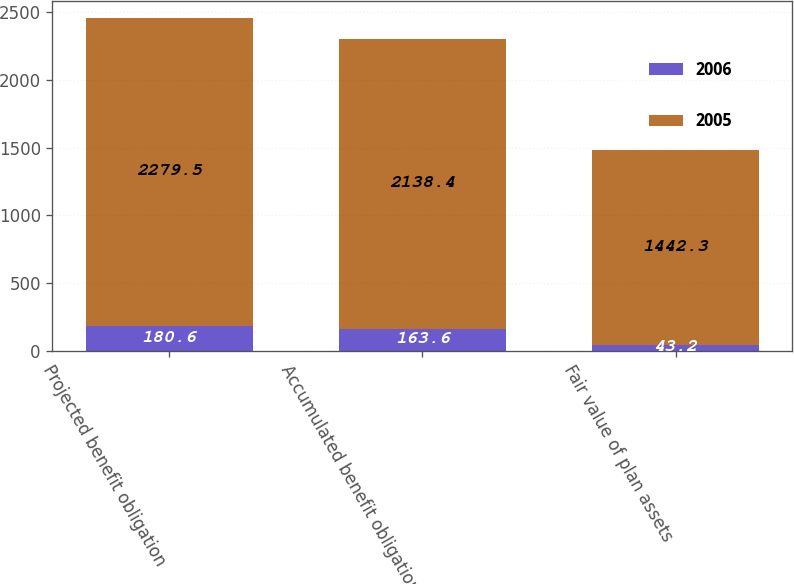Convert chart to OTSL. <chart><loc_0><loc_0><loc_500><loc_500><stacked_bar_chart><ecel><fcel>Projected benefit obligation<fcel>Accumulated benefit obligation<fcel>Fair value of plan assets<nl><fcel>2006<fcel>180.6<fcel>163.6<fcel>43.2<nl><fcel>2005<fcel>2279.5<fcel>2138.4<fcel>1442.3<nl></chart> 